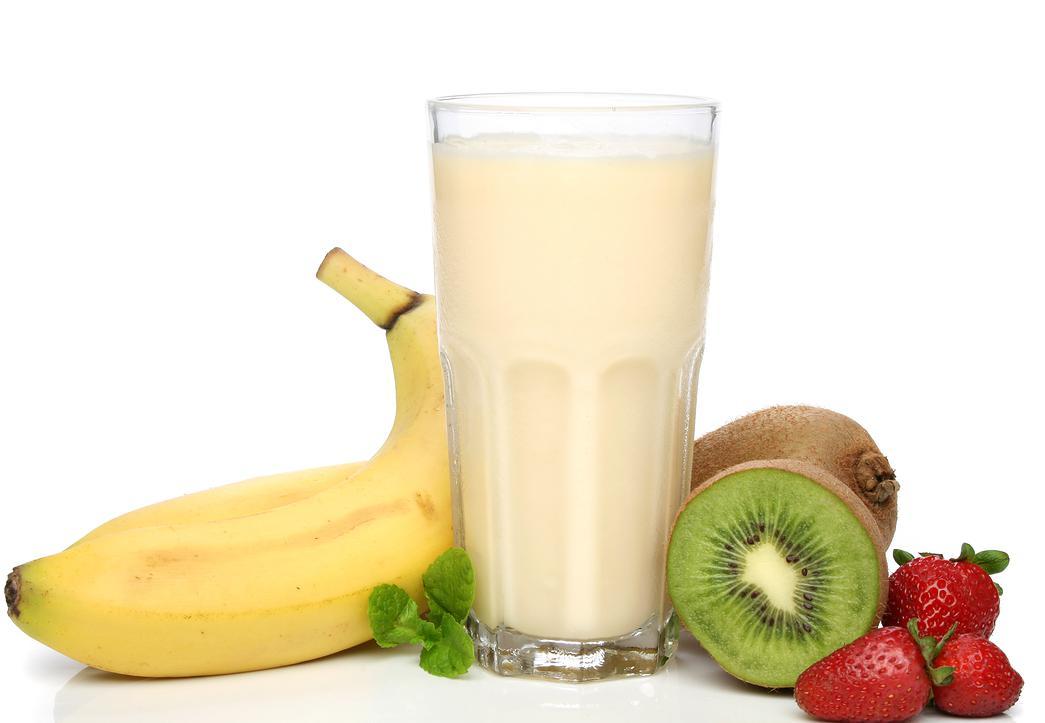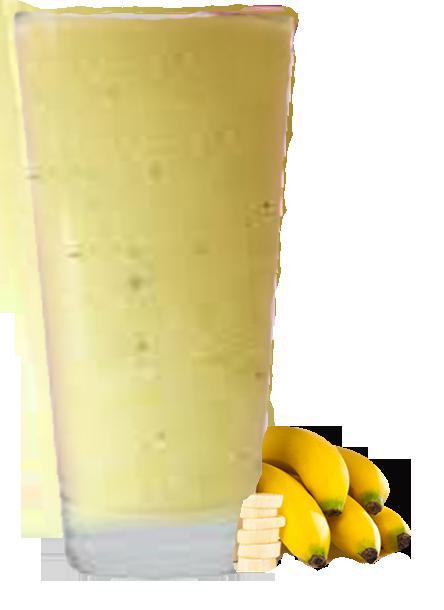The first image is the image on the left, the second image is the image on the right. Evaluate the accuracy of this statement regarding the images: "One of the images has a fruit besides just a banana.". Is it true? Answer yes or no. Yes. 